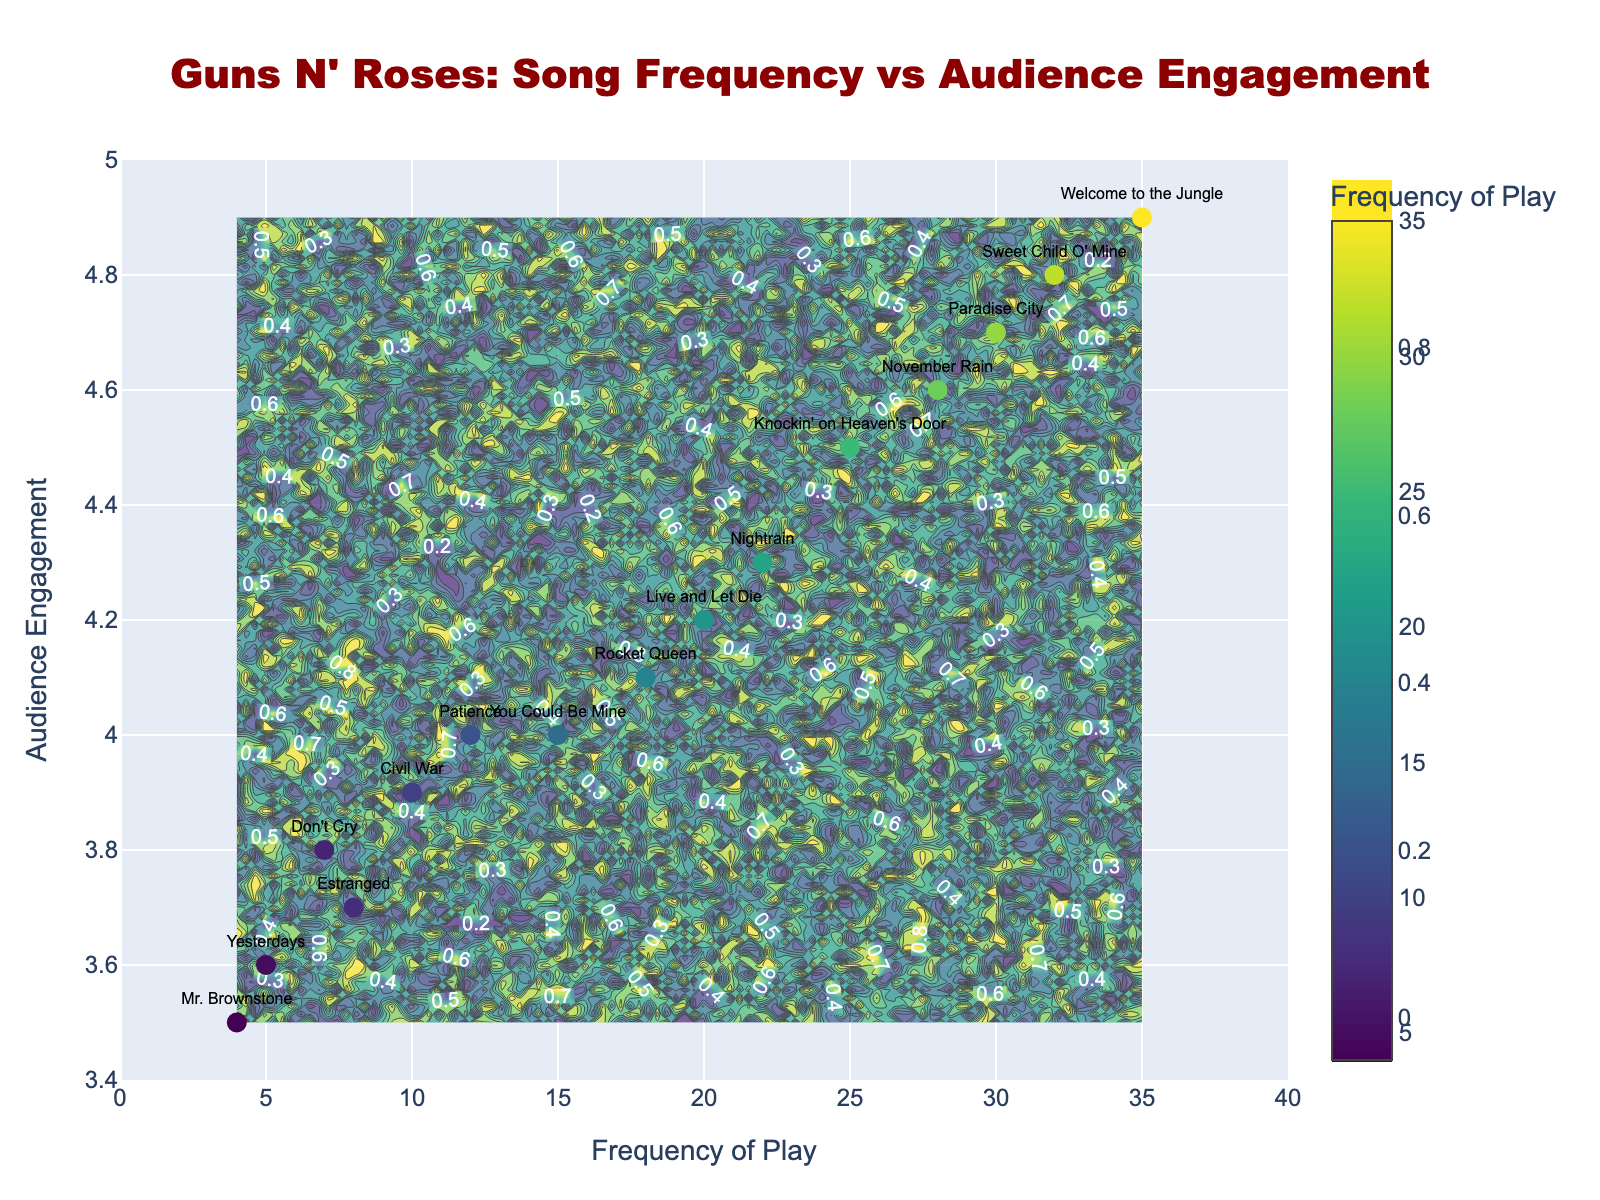What's the title of the figure? The title is located at the top of the figure, often in a larger and distinct font. It is "Guns N' Roses: Song Frequency vs Audience Engagement."
Answer: "Guns N' Roses: Song Frequency vs Audience Engagement" How many songs have a frequency of play greater than 20? Look at the x-axis and identify the data points positioned above 20. Songs with frequencies greater than 20 are "Welcome to the Jungle," "Sweet Child O' Mine," "Paradise City," and "Knockin' on Heaven's Door."
Answer: 4 songs Which song has the highest frequency of play? Locate the highest x-value on the scatter plot and find the corresponding label. "Welcome to the Jungle" is positioned furthest on the x-axis.
Answer: "Welcome to the Jungle" What is the audience engagement score for "November Rain"? Identify the text label "November Rain" on the scatter plot and note its y-value. The y-value for "November Rain" is 4.6.
Answer: 4.6 Which song has the lowest audience engagement score? Find the lowest y-value among the points and identify the corresponding label. The song "Mr. Brownstone" is positioned at the lowest y-value in the figure.
Answer: "Mr. Brownstone" Which two songs have an audience engagement score of 4.0? Look for y-values at 4.0 and find the corresponding labels. The songs "You Could Be Mine" and "Patience" are both at y=4.0.
Answer: "You Could Be Mine" and "Patience" What is the sum of the frequencies of all songs with an audience engagement score above 4.5? Identify the songs with y-values above 4.5 and sum their x-values for frequencies. "Welcome to the Jungle" (35), "Sweet Child O' Mine" (32), "Paradise City" (30), and "November Rain" (28), thus 35 + 32 + 30 + 28 = 125.
Answer: 125 Which song has a higher audience engagement, "Don't Cry" or "Civil War"? Compare the y-values for "Don't Cry" and "Civil War." "Don't Cry" has an engagement score of 3.8 and "Civil War" has 3.9.
Answer: "Civil War" What is the average audience engagement score for songs with a frequency of play less than 10? Identify the songs with x-values less than 10 and average their y-values. Songs are "Estranged," "Don't Cry," "Yesterdays," and "Mr. Brownstone" with engagement scores of 3.7, 3.8, 3.6, and 3.5 respectively. (3.7 + 3.8 + 3.6 + 3.5) / 4 = 3.65
Answer: 3.65 Which song has the highest combination of frequency of play and audience engagement score? Sum the x and y values for each data point and identify the one with the highest total. "Welcome to the Jungle" has the highest values, with 35 + 4.9 = 39.9
Answer: "Welcome to the Jungle" 